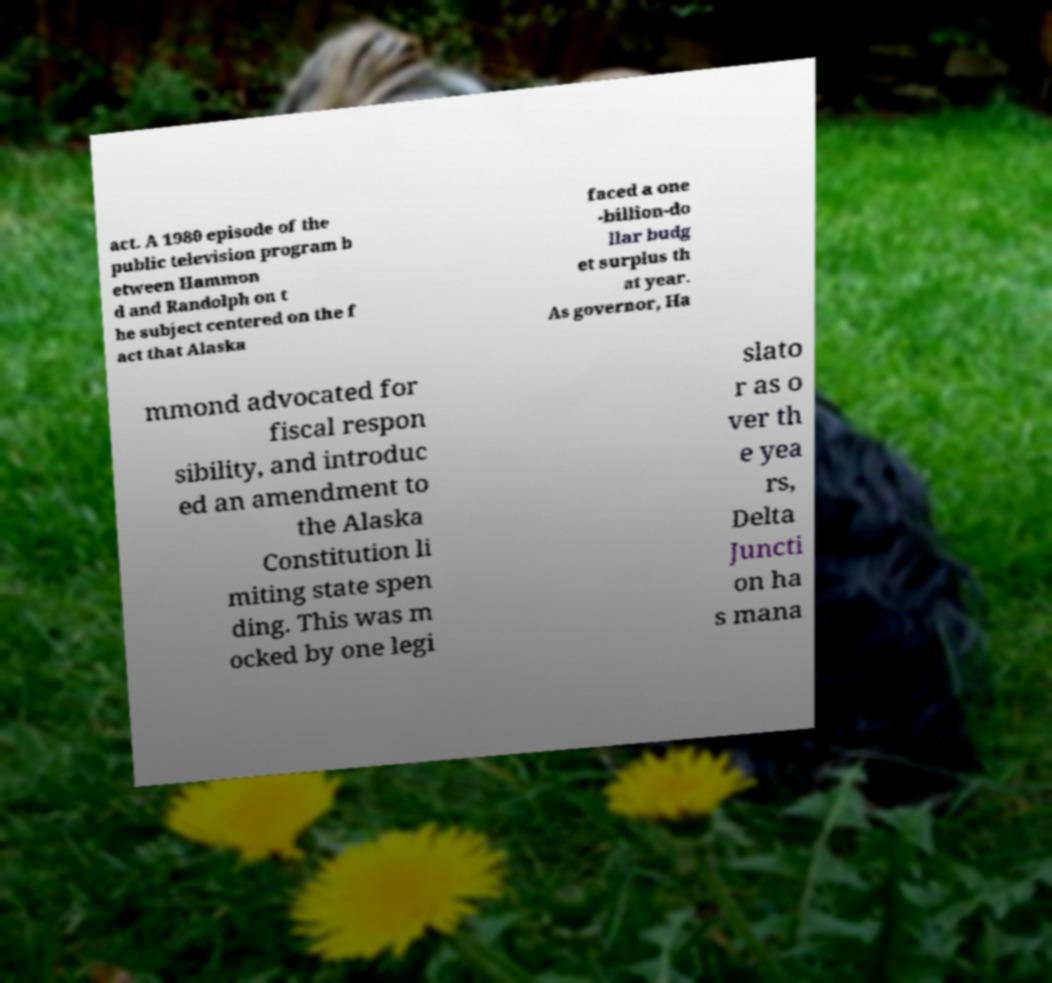Can you accurately transcribe the text from the provided image for me? act. A 1980 episode of the public television program b etween Hammon d and Randolph on t he subject centered on the f act that Alaska faced a one -billion-do llar budg et surplus th at year. As governor, Ha mmond advocated for fiscal respon sibility, and introduc ed an amendment to the Alaska Constitution li miting state spen ding. This was m ocked by one legi slato r as o ver th e yea rs, Delta Juncti on ha s mana 